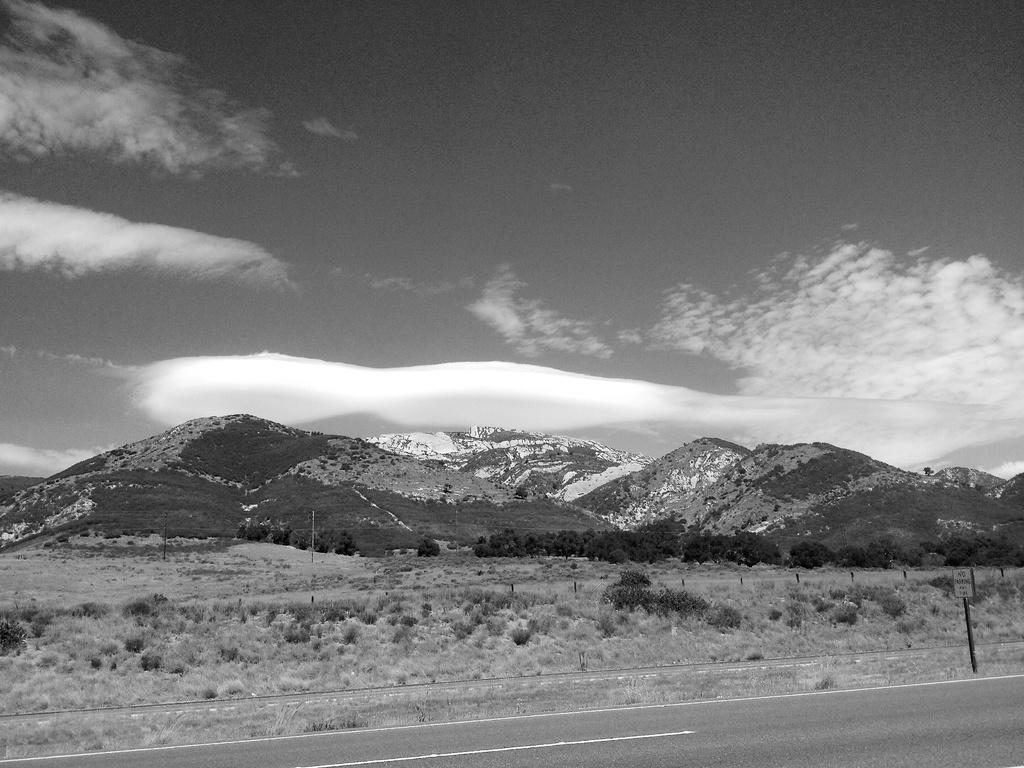What is the main feature of the image? There is a road in the image. What can be seen in the distance behind the road? There are mountains and plants in the background of the image. What else is visible in the background of the image? The sky is visible in the background of the image. What type of ear is visible on the mountain in the image? There is no ear visible on the mountain in the image. What scientific discovery can be made from the plants in the image? The image does not provide any information about scientific discoveries related to the plants. 